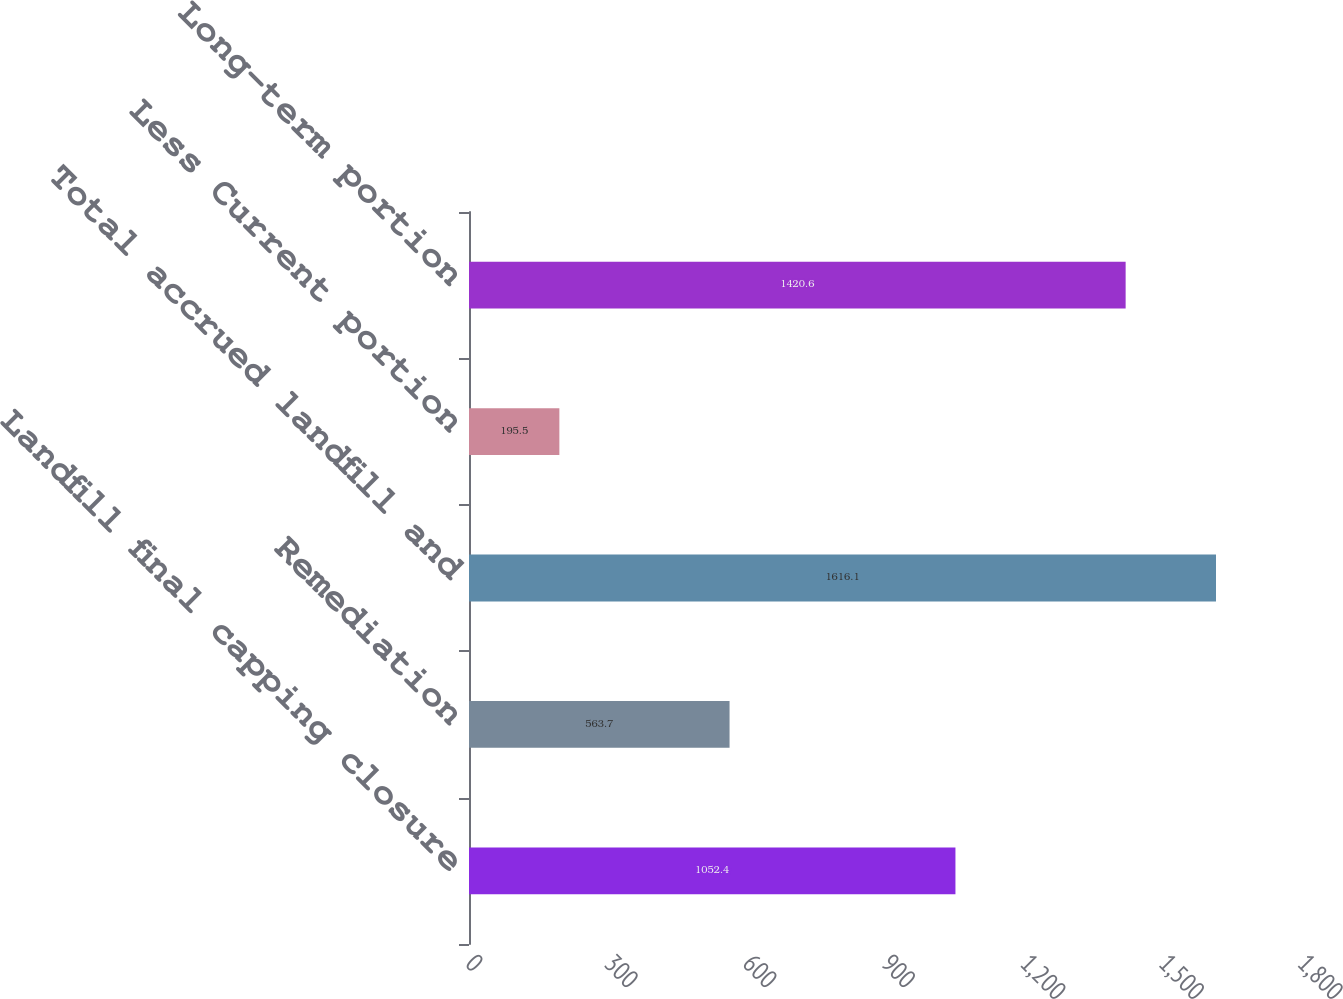<chart> <loc_0><loc_0><loc_500><loc_500><bar_chart><fcel>Landfill final capping closure<fcel>Remediation<fcel>Total accrued landfill and<fcel>Less Current portion<fcel>Long-term portion<nl><fcel>1052.4<fcel>563.7<fcel>1616.1<fcel>195.5<fcel>1420.6<nl></chart> 